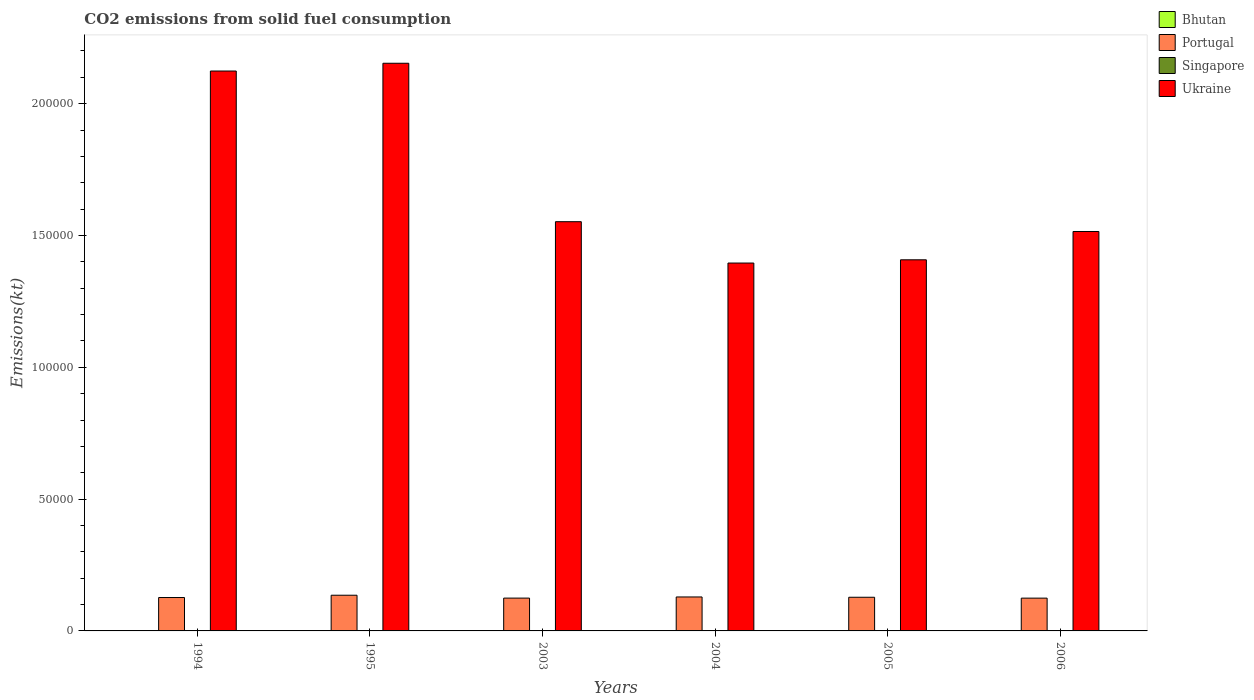Are the number of bars per tick equal to the number of legend labels?
Offer a very short reply. Yes. How many bars are there on the 6th tick from the left?
Your answer should be compact. 4. How many bars are there on the 6th tick from the right?
Keep it short and to the point. 4. What is the label of the 3rd group of bars from the left?
Provide a short and direct response. 2003. What is the amount of CO2 emitted in Ukraine in 2005?
Make the answer very short. 1.41e+05. Across all years, what is the maximum amount of CO2 emitted in Bhutan?
Offer a very short reply. 110.01. Across all years, what is the minimum amount of CO2 emitted in Portugal?
Offer a terse response. 1.24e+04. In which year was the amount of CO2 emitted in Ukraine maximum?
Ensure brevity in your answer.  1995. In which year was the amount of CO2 emitted in Bhutan minimum?
Offer a terse response. 2004. What is the total amount of CO2 emitted in Portugal in the graph?
Your response must be concise. 7.68e+04. What is the difference between the amount of CO2 emitted in Portugal in 2005 and that in 2006?
Offer a terse response. 333.7. What is the difference between the amount of CO2 emitted in Bhutan in 2003 and the amount of CO2 emitted in Ukraine in 2004?
Give a very brief answer. -1.39e+05. What is the average amount of CO2 emitted in Portugal per year?
Your answer should be compact. 1.28e+04. In the year 2005, what is the difference between the amount of CO2 emitted in Portugal and amount of CO2 emitted in Singapore?
Make the answer very short. 1.28e+04. In how many years, is the amount of CO2 emitted in Ukraine greater than 130000 kt?
Make the answer very short. 6. What is the ratio of the amount of CO2 emitted in Ukraine in 2004 to that in 2005?
Offer a very short reply. 0.99. Is the difference between the amount of CO2 emitted in Portugal in 1995 and 2005 greater than the difference between the amount of CO2 emitted in Singapore in 1995 and 2005?
Your answer should be compact. Yes. What is the difference between the highest and the second highest amount of CO2 emitted in Bhutan?
Your answer should be very brief. 11. What is the difference between the highest and the lowest amount of CO2 emitted in Bhutan?
Ensure brevity in your answer.  84.34. In how many years, is the amount of CO2 emitted in Portugal greater than the average amount of CO2 emitted in Portugal taken over all years?
Give a very brief answer. 2. Is it the case that in every year, the sum of the amount of CO2 emitted in Ukraine and amount of CO2 emitted in Singapore is greater than the sum of amount of CO2 emitted in Portugal and amount of CO2 emitted in Bhutan?
Make the answer very short. Yes. What does the 2nd bar from the left in 1995 represents?
Keep it short and to the point. Portugal. What does the 4th bar from the right in 1995 represents?
Give a very brief answer. Bhutan. Is it the case that in every year, the sum of the amount of CO2 emitted in Bhutan and amount of CO2 emitted in Ukraine is greater than the amount of CO2 emitted in Singapore?
Keep it short and to the point. Yes. Are all the bars in the graph horizontal?
Offer a terse response. No. Are the values on the major ticks of Y-axis written in scientific E-notation?
Your answer should be compact. No. Where does the legend appear in the graph?
Your answer should be compact. Top right. How many legend labels are there?
Offer a very short reply. 4. What is the title of the graph?
Ensure brevity in your answer.  CO2 emissions from solid fuel consumption. Does "Brazil" appear as one of the legend labels in the graph?
Offer a terse response. No. What is the label or title of the X-axis?
Give a very brief answer. Years. What is the label or title of the Y-axis?
Your response must be concise. Emissions(kt). What is the Emissions(kt) in Bhutan in 1994?
Provide a succinct answer. 62.34. What is the Emissions(kt) of Portugal in 1994?
Give a very brief answer. 1.27e+04. What is the Emissions(kt) of Singapore in 1994?
Your response must be concise. 88.01. What is the Emissions(kt) in Ukraine in 1994?
Your response must be concise. 2.12e+05. What is the Emissions(kt) of Bhutan in 1995?
Make the answer very short. 77.01. What is the Emissions(kt) in Portugal in 1995?
Your answer should be very brief. 1.35e+04. What is the Emissions(kt) in Singapore in 1995?
Offer a very short reply. 40.34. What is the Emissions(kt) in Ukraine in 1995?
Your answer should be very brief. 2.15e+05. What is the Emissions(kt) of Bhutan in 2003?
Provide a succinct answer. 110.01. What is the Emissions(kt) of Portugal in 2003?
Offer a very short reply. 1.24e+04. What is the Emissions(kt) of Singapore in 2003?
Provide a short and direct response. 33. What is the Emissions(kt) of Ukraine in 2003?
Provide a succinct answer. 1.55e+05. What is the Emissions(kt) in Bhutan in 2004?
Give a very brief answer. 25.67. What is the Emissions(kt) of Portugal in 2004?
Provide a short and direct response. 1.29e+04. What is the Emissions(kt) of Singapore in 2004?
Make the answer very short. 40.34. What is the Emissions(kt) in Ukraine in 2004?
Provide a short and direct response. 1.40e+05. What is the Emissions(kt) in Bhutan in 2005?
Offer a very short reply. 99.01. What is the Emissions(kt) in Portugal in 2005?
Offer a very short reply. 1.28e+04. What is the Emissions(kt) of Singapore in 2005?
Give a very brief answer. 11. What is the Emissions(kt) in Ukraine in 2005?
Your answer should be very brief. 1.41e+05. What is the Emissions(kt) of Bhutan in 2006?
Make the answer very short. 84.34. What is the Emissions(kt) of Portugal in 2006?
Provide a succinct answer. 1.24e+04. What is the Emissions(kt) of Singapore in 2006?
Your response must be concise. 14.67. What is the Emissions(kt) in Ukraine in 2006?
Make the answer very short. 1.52e+05. Across all years, what is the maximum Emissions(kt) in Bhutan?
Your response must be concise. 110.01. Across all years, what is the maximum Emissions(kt) of Portugal?
Your answer should be compact. 1.35e+04. Across all years, what is the maximum Emissions(kt) of Singapore?
Provide a short and direct response. 88.01. Across all years, what is the maximum Emissions(kt) in Ukraine?
Provide a short and direct response. 2.15e+05. Across all years, what is the minimum Emissions(kt) of Bhutan?
Offer a very short reply. 25.67. Across all years, what is the minimum Emissions(kt) in Portugal?
Make the answer very short. 1.24e+04. Across all years, what is the minimum Emissions(kt) in Singapore?
Keep it short and to the point. 11. Across all years, what is the minimum Emissions(kt) in Ukraine?
Provide a succinct answer. 1.40e+05. What is the total Emissions(kt) of Bhutan in the graph?
Offer a very short reply. 458.38. What is the total Emissions(kt) in Portugal in the graph?
Make the answer very short. 7.68e+04. What is the total Emissions(kt) of Singapore in the graph?
Your answer should be compact. 227.35. What is the total Emissions(kt) in Ukraine in the graph?
Your answer should be compact. 1.01e+06. What is the difference between the Emissions(kt) of Bhutan in 1994 and that in 1995?
Offer a very short reply. -14.67. What is the difference between the Emissions(kt) in Portugal in 1994 and that in 1995?
Give a very brief answer. -869.08. What is the difference between the Emissions(kt) in Singapore in 1994 and that in 1995?
Your answer should be compact. 47.67. What is the difference between the Emissions(kt) of Ukraine in 1994 and that in 1995?
Provide a short and direct response. -2948.27. What is the difference between the Emissions(kt) in Bhutan in 1994 and that in 2003?
Your answer should be very brief. -47.67. What is the difference between the Emissions(kt) in Portugal in 1994 and that in 2003?
Your answer should be compact. 220.02. What is the difference between the Emissions(kt) of Singapore in 1994 and that in 2003?
Provide a short and direct response. 55.01. What is the difference between the Emissions(kt) of Ukraine in 1994 and that in 2003?
Provide a succinct answer. 5.72e+04. What is the difference between the Emissions(kt) in Bhutan in 1994 and that in 2004?
Provide a short and direct response. 36.67. What is the difference between the Emissions(kt) of Portugal in 1994 and that in 2004?
Keep it short and to the point. -216.35. What is the difference between the Emissions(kt) in Singapore in 1994 and that in 2004?
Offer a very short reply. 47.67. What is the difference between the Emissions(kt) of Ukraine in 1994 and that in 2004?
Your response must be concise. 7.28e+04. What is the difference between the Emissions(kt) in Bhutan in 1994 and that in 2005?
Make the answer very short. -36.67. What is the difference between the Emissions(kt) of Portugal in 1994 and that in 2005?
Give a very brief answer. -102.68. What is the difference between the Emissions(kt) of Singapore in 1994 and that in 2005?
Offer a very short reply. 77.01. What is the difference between the Emissions(kt) of Ukraine in 1994 and that in 2005?
Give a very brief answer. 7.16e+04. What is the difference between the Emissions(kt) of Bhutan in 1994 and that in 2006?
Your response must be concise. -22. What is the difference between the Emissions(kt) in Portugal in 1994 and that in 2006?
Your response must be concise. 231.02. What is the difference between the Emissions(kt) of Singapore in 1994 and that in 2006?
Your answer should be compact. 73.34. What is the difference between the Emissions(kt) of Ukraine in 1994 and that in 2006?
Your answer should be very brief. 6.09e+04. What is the difference between the Emissions(kt) of Bhutan in 1995 and that in 2003?
Offer a very short reply. -33. What is the difference between the Emissions(kt) in Portugal in 1995 and that in 2003?
Your answer should be compact. 1089.1. What is the difference between the Emissions(kt) in Singapore in 1995 and that in 2003?
Give a very brief answer. 7.33. What is the difference between the Emissions(kt) in Ukraine in 1995 and that in 2003?
Provide a short and direct response. 6.01e+04. What is the difference between the Emissions(kt) of Bhutan in 1995 and that in 2004?
Provide a short and direct response. 51.34. What is the difference between the Emissions(kt) in Portugal in 1995 and that in 2004?
Offer a very short reply. 652.73. What is the difference between the Emissions(kt) in Singapore in 1995 and that in 2004?
Give a very brief answer. 0. What is the difference between the Emissions(kt) of Ukraine in 1995 and that in 2004?
Your response must be concise. 7.58e+04. What is the difference between the Emissions(kt) in Bhutan in 1995 and that in 2005?
Your response must be concise. -22. What is the difference between the Emissions(kt) of Portugal in 1995 and that in 2005?
Offer a very short reply. 766.4. What is the difference between the Emissions(kt) of Singapore in 1995 and that in 2005?
Your response must be concise. 29.34. What is the difference between the Emissions(kt) of Ukraine in 1995 and that in 2005?
Provide a short and direct response. 7.46e+04. What is the difference between the Emissions(kt) of Bhutan in 1995 and that in 2006?
Your answer should be compact. -7.33. What is the difference between the Emissions(kt) of Portugal in 1995 and that in 2006?
Provide a short and direct response. 1100.1. What is the difference between the Emissions(kt) in Singapore in 1995 and that in 2006?
Offer a terse response. 25.67. What is the difference between the Emissions(kt) in Ukraine in 1995 and that in 2006?
Offer a terse response. 6.38e+04. What is the difference between the Emissions(kt) in Bhutan in 2003 and that in 2004?
Offer a very short reply. 84.34. What is the difference between the Emissions(kt) in Portugal in 2003 and that in 2004?
Your answer should be compact. -436.37. What is the difference between the Emissions(kt) of Singapore in 2003 and that in 2004?
Provide a short and direct response. -7.33. What is the difference between the Emissions(kt) in Ukraine in 2003 and that in 2004?
Keep it short and to the point. 1.57e+04. What is the difference between the Emissions(kt) in Bhutan in 2003 and that in 2005?
Ensure brevity in your answer.  11. What is the difference between the Emissions(kt) in Portugal in 2003 and that in 2005?
Provide a short and direct response. -322.7. What is the difference between the Emissions(kt) in Singapore in 2003 and that in 2005?
Make the answer very short. 22. What is the difference between the Emissions(kt) of Ukraine in 2003 and that in 2005?
Ensure brevity in your answer.  1.45e+04. What is the difference between the Emissions(kt) in Bhutan in 2003 and that in 2006?
Offer a very short reply. 25.67. What is the difference between the Emissions(kt) of Portugal in 2003 and that in 2006?
Provide a short and direct response. 11. What is the difference between the Emissions(kt) of Singapore in 2003 and that in 2006?
Ensure brevity in your answer.  18.34. What is the difference between the Emissions(kt) in Ukraine in 2003 and that in 2006?
Offer a very short reply. 3714.67. What is the difference between the Emissions(kt) in Bhutan in 2004 and that in 2005?
Provide a short and direct response. -73.34. What is the difference between the Emissions(kt) of Portugal in 2004 and that in 2005?
Your answer should be very brief. 113.68. What is the difference between the Emissions(kt) in Singapore in 2004 and that in 2005?
Offer a terse response. 29.34. What is the difference between the Emissions(kt) of Ukraine in 2004 and that in 2005?
Offer a very short reply. -1224.78. What is the difference between the Emissions(kt) in Bhutan in 2004 and that in 2006?
Your response must be concise. -58.67. What is the difference between the Emissions(kt) in Portugal in 2004 and that in 2006?
Make the answer very short. 447.37. What is the difference between the Emissions(kt) of Singapore in 2004 and that in 2006?
Your response must be concise. 25.67. What is the difference between the Emissions(kt) in Ukraine in 2004 and that in 2006?
Your answer should be compact. -1.20e+04. What is the difference between the Emissions(kt) in Bhutan in 2005 and that in 2006?
Provide a succinct answer. 14.67. What is the difference between the Emissions(kt) in Portugal in 2005 and that in 2006?
Your response must be concise. 333.7. What is the difference between the Emissions(kt) of Singapore in 2005 and that in 2006?
Give a very brief answer. -3.67. What is the difference between the Emissions(kt) of Ukraine in 2005 and that in 2006?
Provide a succinct answer. -1.07e+04. What is the difference between the Emissions(kt) of Bhutan in 1994 and the Emissions(kt) of Portugal in 1995?
Make the answer very short. -1.35e+04. What is the difference between the Emissions(kt) of Bhutan in 1994 and the Emissions(kt) of Singapore in 1995?
Give a very brief answer. 22. What is the difference between the Emissions(kt) of Bhutan in 1994 and the Emissions(kt) of Ukraine in 1995?
Provide a succinct answer. -2.15e+05. What is the difference between the Emissions(kt) of Portugal in 1994 and the Emissions(kt) of Singapore in 1995?
Provide a short and direct response. 1.26e+04. What is the difference between the Emissions(kt) in Portugal in 1994 and the Emissions(kt) in Ukraine in 1995?
Give a very brief answer. -2.03e+05. What is the difference between the Emissions(kt) in Singapore in 1994 and the Emissions(kt) in Ukraine in 1995?
Your answer should be very brief. -2.15e+05. What is the difference between the Emissions(kt) of Bhutan in 1994 and the Emissions(kt) of Portugal in 2003?
Give a very brief answer. -1.24e+04. What is the difference between the Emissions(kt) in Bhutan in 1994 and the Emissions(kt) in Singapore in 2003?
Ensure brevity in your answer.  29.34. What is the difference between the Emissions(kt) of Bhutan in 1994 and the Emissions(kt) of Ukraine in 2003?
Provide a succinct answer. -1.55e+05. What is the difference between the Emissions(kt) of Portugal in 1994 and the Emissions(kt) of Singapore in 2003?
Ensure brevity in your answer.  1.26e+04. What is the difference between the Emissions(kt) of Portugal in 1994 and the Emissions(kt) of Ukraine in 2003?
Offer a terse response. -1.43e+05. What is the difference between the Emissions(kt) of Singapore in 1994 and the Emissions(kt) of Ukraine in 2003?
Provide a succinct answer. -1.55e+05. What is the difference between the Emissions(kt) of Bhutan in 1994 and the Emissions(kt) of Portugal in 2004?
Keep it short and to the point. -1.28e+04. What is the difference between the Emissions(kt) in Bhutan in 1994 and the Emissions(kt) in Singapore in 2004?
Ensure brevity in your answer.  22. What is the difference between the Emissions(kt) in Bhutan in 1994 and the Emissions(kt) in Ukraine in 2004?
Offer a very short reply. -1.40e+05. What is the difference between the Emissions(kt) of Portugal in 1994 and the Emissions(kt) of Singapore in 2004?
Your answer should be compact. 1.26e+04. What is the difference between the Emissions(kt) in Portugal in 1994 and the Emissions(kt) in Ukraine in 2004?
Make the answer very short. -1.27e+05. What is the difference between the Emissions(kt) in Singapore in 1994 and the Emissions(kt) in Ukraine in 2004?
Provide a succinct answer. -1.39e+05. What is the difference between the Emissions(kt) in Bhutan in 1994 and the Emissions(kt) in Portugal in 2005?
Ensure brevity in your answer.  -1.27e+04. What is the difference between the Emissions(kt) in Bhutan in 1994 and the Emissions(kt) in Singapore in 2005?
Your answer should be compact. 51.34. What is the difference between the Emissions(kt) in Bhutan in 1994 and the Emissions(kt) in Ukraine in 2005?
Make the answer very short. -1.41e+05. What is the difference between the Emissions(kt) in Portugal in 1994 and the Emissions(kt) in Singapore in 2005?
Your answer should be compact. 1.27e+04. What is the difference between the Emissions(kt) in Portugal in 1994 and the Emissions(kt) in Ukraine in 2005?
Offer a terse response. -1.28e+05. What is the difference between the Emissions(kt) in Singapore in 1994 and the Emissions(kt) in Ukraine in 2005?
Make the answer very short. -1.41e+05. What is the difference between the Emissions(kt) of Bhutan in 1994 and the Emissions(kt) of Portugal in 2006?
Make the answer very short. -1.24e+04. What is the difference between the Emissions(kt) of Bhutan in 1994 and the Emissions(kt) of Singapore in 2006?
Provide a succinct answer. 47.67. What is the difference between the Emissions(kt) in Bhutan in 1994 and the Emissions(kt) in Ukraine in 2006?
Your response must be concise. -1.51e+05. What is the difference between the Emissions(kt) in Portugal in 1994 and the Emissions(kt) in Singapore in 2006?
Offer a very short reply. 1.27e+04. What is the difference between the Emissions(kt) of Portugal in 1994 and the Emissions(kt) of Ukraine in 2006?
Your answer should be very brief. -1.39e+05. What is the difference between the Emissions(kt) in Singapore in 1994 and the Emissions(kt) in Ukraine in 2006?
Provide a short and direct response. -1.51e+05. What is the difference between the Emissions(kt) of Bhutan in 1995 and the Emissions(kt) of Portugal in 2003?
Offer a very short reply. -1.24e+04. What is the difference between the Emissions(kt) of Bhutan in 1995 and the Emissions(kt) of Singapore in 2003?
Your answer should be compact. 44. What is the difference between the Emissions(kt) of Bhutan in 1995 and the Emissions(kt) of Ukraine in 2003?
Offer a terse response. -1.55e+05. What is the difference between the Emissions(kt) of Portugal in 1995 and the Emissions(kt) of Singapore in 2003?
Provide a succinct answer. 1.35e+04. What is the difference between the Emissions(kt) of Portugal in 1995 and the Emissions(kt) of Ukraine in 2003?
Keep it short and to the point. -1.42e+05. What is the difference between the Emissions(kt) of Singapore in 1995 and the Emissions(kt) of Ukraine in 2003?
Your response must be concise. -1.55e+05. What is the difference between the Emissions(kt) of Bhutan in 1995 and the Emissions(kt) of Portugal in 2004?
Keep it short and to the point. -1.28e+04. What is the difference between the Emissions(kt) of Bhutan in 1995 and the Emissions(kt) of Singapore in 2004?
Offer a very short reply. 36.67. What is the difference between the Emissions(kt) in Bhutan in 1995 and the Emissions(kt) in Ukraine in 2004?
Offer a very short reply. -1.39e+05. What is the difference between the Emissions(kt) in Portugal in 1995 and the Emissions(kt) in Singapore in 2004?
Offer a very short reply. 1.35e+04. What is the difference between the Emissions(kt) of Portugal in 1995 and the Emissions(kt) of Ukraine in 2004?
Make the answer very short. -1.26e+05. What is the difference between the Emissions(kt) of Singapore in 1995 and the Emissions(kt) of Ukraine in 2004?
Keep it short and to the point. -1.40e+05. What is the difference between the Emissions(kt) of Bhutan in 1995 and the Emissions(kt) of Portugal in 2005?
Give a very brief answer. -1.27e+04. What is the difference between the Emissions(kt) of Bhutan in 1995 and the Emissions(kt) of Singapore in 2005?
Provide a short and direct response. 66.01. What is the difference between the Emissions(kt) of Bhutan in 1995 and the Emissions(kt) of Ukraine in 2005?
Make the answer very short. -1.41e+05. What is the difference between the Emissions(kt) in Portugal in 1995 and the Emissions(kt) in Singapore in 2005?
Provide a short and direct response. 1.35e+04. What is the difference between the Emissions(kt) of Portugal in 1995 and the Emissions(kt) of Ukraine in 2005?
Provide a succinct answer. -1.27e+05. What is the difference between the Emissions(kt) in Singapore in 1995 and the Emissions(kt) in Ukraine in 2005?
Your response must be concise. -1.41e+05. What is the difference between the Emissions(kt) of Bhutan in 1995 and the Emissions(kt) of Portugal in 2006?
Make the answer very short. -1.24e+04. What is the difference between the Emissions(kt) in Bhutan in 1995 and the Emissions(kt) in Singapore in 2006?
Keep it short and to the point. 62.34. What is the difference between the Emissions(kt) of Bhutan in 1995 and the Emissions(kt) of Ukraine in 2006?
Make the answer very short. -1.51e+05. What is the difference between the Emissions(kt) of Portugal in 1995 and the Emissions(kt) of Singapore in 2006?
Your answer should be compact. 1.35e+04. What is the difference between the Emissions(kt) in Portugal in 1995 and the Emissions(kt) in Ukraine in 2006?
Make the answer very short. -1.38e+05. What is the difference between the Emissions(kt) of Singapore in 1995 and the Emissions(kt) of Ukraine in 2006?
Offer a terse response. -1.51e+05. What is the difference between the Emissions(kt) in Bhutan in 2003 and the Emissions(kt) in Portugal in 2004?
Your answer should be compact. -1.28e+04. What is the difference between the Emissions(kt) in Bhutan in 2003 and the Emissions(kt) in Singapore in 2004?
Your answer should be very brief. 69.67. What is the difference between the Emissions(kt) of Bhutan in 2003 and the Emissions(kt) of Ukraine in 2004?
Your response must be concise. -1.39e+05. What is the difference between the Emissions(kt) of Portugal in 2003 and the Emissions(kt) of Singapore in 2004?
Offer a terse response. 1.24e+04. What is the difference between the Emissions(kt) in Portugal in 2003 and the Emissions(kt) in Ukraine in 2004?
Keep it short and to the point. -1.27e+05. What is the difference between the Emissions(kt) of Singapore in 2003 and the Emissions(kt) of Ukraine in 2004?
Make the answer very short. -1.40e+05. What is the difference between the Emissions(kt) in Bhutan in 2003 and the Emissions(kt) in Portugal in 2005?
Make the answer very short. -1.27e+04. What is the difference between the Emissions(kt) of Bhutan in 2003 and the Emissions(kt) of Singapore in 2005?
Provide a short and direct response. 99.01. What is the difference between the Emissions(kt) in Bhutan in 2003 and the Emissions(kt) in Ukraine in 2005?
Provide a succinct answer. -1.41e+05. What is the difference between the Emissions(kt) in Portugal in 2003 and the Emissions(kt) in Singapore in 2005?
Keep it short and to the point. 1.24e+04. What is the difference between the Emissions(kt) in Portugal in 2003 and the Emissions(kt) in Ukraine in 2005?
Make the answer very short. -1.28e+05. What is the difference between the Emissions(kt) of Singapore in 2003 and the Emissions(kt) of Ukraine in 2005?
Provide a succinct answer. -1.41e+05. What is the difference between the Emissions(kt) in Bhutan in 2003 and the Emissions(kt) in Portugal in 2006?
Provide a short and direct response. -1.23e+04. What is the difference between the Emissions(kt) in Bhutan in 2003 and the Emissions(kt) in Singapore in 2006?
Provide a succinct answer. 95.34. What is the difference between the Emissions(kt) of Bhutan in 2003 and the Emissions(kt) of Ukraine in 2006?
Provide a succinct answer. -1.51e+05. What is the difference between the Emissions(kt) in Portugal in 2003 and the Emissions(kt) in Singapore in 2006?
Provide a succinct answer. 1.24e+04. What is the difference between the Emissions(kt) in Portugal in 2003 and the Emissions(kt) in Ukraine in 2006?
Offer a terse response. -1.39e+05. What is the difference between the Emissions(kt) of Singapore in 2003 and the Emissions(kt) of Ukraine in 2006?
Keep it short and to the point. -1.51e+05. What is the difference between the Emissions(kt) of Bhutan in 2004 and the Emissions(kt) of Portugal in 2005?
Your response must be concise. -1.27e+04. What is the difference between the Emissions(kt) in Bhutan in 2004 and the Emissions(kt) in Singapore in 2005?
Provide a succinct answer. 14.67. What is the difference between the Emissions(kt) in Bhutan in 2004 and the Emissions(kt) in Ukraine in 2005?
Your response must be concise. -1.41e+05. What is the difference between the Emissions(kt) of Portugal in 2004 and the Emissions(kt) of Singapore in 2005?
Ensure brevity in your answer.  1.29e+04. What is the difference between the Emissions(kt) in Portugal in 2004 and the Emissions(kt) in Ukraine in 2005?
Your answer should be compact. -1.28e+05. What is the difference between the Emissions(kt) in Singapore in 2004 and the Emissions(kt) in Ukraine in 2005?
Ensure brevity in your answer.  -1.41e+05. What is the difference between the Emissions(kt) in Bhutan in 2004 and the Emissions(kt) in Portugal in 2006?
Offer a terse response. -1.24e+04. What is the difference between the Emissions(kt) in Bhutan in 2004 and the Emissions(kt) in Singapore in 2006?
Keep it short and to the point. 11. What is the difference between the Emissions(kt) in Bhutan in 2004 and the Emissions(kt) in Ukraine in 2006?
Offer a very short reply. -1.52e+05. What is the difference between the Emissions(kt) in Portugal in 2004 and the Emissions(kt) in Singapore in 2006?
Your response must be concise. 1.29e+04. What is the difference between the Emissions(kt) of Portugal in 2004 and the Emissions(kt) of Ukraine in 2006?
Make the answer very short. -1.39e+05. What is the difference between the Emissions(kt) in Singapore in 2004 and the Emissions(kt) in Ukraine in 2006?
Offer a terse response. -1.51e+05. What is the difference between the Emissions(kt) of Bhutan in 2005 and the Emissions(kt) of Portugal in 2006?
Give a very brief answer. -1.23e+04. What is the difference between the Emissions(kt) in Bhutan in 2005 and the Emissions(kt) in Singapore in 2006?
Offer a very short reply. 84.34. What is the difference between the Emissions(kt) of Bhutan in 2005 and the Emissions(kt) of Ukraine in 2006?
Offer a terse response. -1.51e+05. What is the difference between the Emissions(kt) in Portugal in 2005 and the Emissions(kt) in Singapore in 2006?
Keep it short and to the point. 1.28e+04. What is the difference between the Emissions(kt) of Portugal in 2005 and the Emissions(kt) of Ukraine in 2006?
Provide a succinct answer. -1.39e+05. What is the difference between the Emissions(kt) of Singapore in 2005 and the Emissions(kt) of Ukraine in 2006?
Your response must be concise. -1.52e+05. What is the average Emissions(kt) of Bhutan per year?
Your answer should be compact. 76.4. What is the average Emissions(kt) of Portugal per year?
Offer a terse response. 1.28e+04. What is the average Emissions(kt) in Singapore per year?
Your response must be concise. 37.89. What is the average Emissions(kt) of Ukraine per year?
Make the answer very short. 1.69e+05. In the year 1994, what is the difference between the Emissions(kt) of Bhutan and Emissions(kt) of Portugal?
Your answer should be compact. -1.26e+04. In the year 1994, what is the difference between the Emissions(kt) of Bhutan and Emissions(kt) of Singapore?
Make the answer very short. -25.67. In the year 1994, what is the difference between the Emissions(kt) in Bhutan and Emissions(kt) in Ukraine?
Provide a short and direct response. -2.12e+05. In the year 1994, what is the difference between the Emissions(kt) in Portugal and Emissions(kt) in Singapore?
Offer a very short reply. 1.26e+04. In the year 1994, what is the difference between the Emissions(kt) of Portugal and Emissions(kt) of Ukraine?
Your response must be concise. -2.00e+05. In the year 1994, what is the difference between the Emissions(kt) of Singapore and Emissions(kt) of Ukraine?
Ensure brevity in your answer.  -2.12e+05. In the year 1995, what is the difference between the Emissions(kt) of Bhutan and Emissions(kt) of Portugal?
Provide a short and direct response. -1.35e+04. In the year 1995, what is the difference between the Emissions(kt) of Bhutan and Emissions(kt) of Singapore?
Your answer should be compact. 36.67. In the year 1995, what is the difference between the Emissions(kt) in Bhutan and Emissions(kt) in Ukraine?
Make the answer very short. -2.15e+05. In the year 1995, what is the difference between the Emissions(kt) in Portugal and Emissions(kt) in Singapore?
Offer a terse response. 1.35e+04. In the year 1995, what is the difference between the Emissions(kt) of Portugal and Emissions(kt) of Ukraine?
Provide a short and direct response. -2.02e+05. In the year 1995, what is the difference between the Emissions(kt) of Singapore and Emissions(kt) of Ukraine?
Provide a succinct answer. -2.15e+05. In the year 2003, what is the difference between the Emissions(kt) in Bhutan and Emissions(kt) in Portugal?
Provide a succinct answer. -1.23e+04. In the year 2003, what is the difference between the Emissions(kt) in Bhutan and Emissions(kt) in Singapore?
Make the answer very short. 77.01. In the year 2003, what is the difference between the Emissions(kt) of Bhutan and Emissions(kt) of Ukraine?
Offer a very short reply. -1.55e+05. In the year 2003, what is the difference between the Emissions(kt) of Portugal and Emissions(kt) of Singapore?
Make the answer very short. 1.24e+04. In the year 2003, what is the difference between the Emissions(kt) of Portugal and Emissions(kt) of Ukraine?
Provide a succinct answer. -1.43e+05. In the year 2003, what is the difference between the Emissions(kt) in Singapore and Emissions(kt) in Ukraine?
Ensure brevity in your answer.  -1.55e+05. In the year 2004, what is the difference between the Emissions(kt) of Bhutan and Emissions(kt) of Portugal?
Provide a succinct answer. -1.29e+04. In the year 2004, what is the difference between the Emissions(kt) in Bhutan and Emissions(kt) in Singapore?
Give a very brief answer. -14.67. In the year 2004, what is the difference between the Emissions(kt) of Bhutan and Emissions(kt) of Ukraine?
Ensure brevity in your answer.  -1.40e+05. In the year 2004, what is the difference between the Emissions(kt) in Portugal and Emissions(kt) in Singapore?
Make the answer very short. 1.28e+04. In the year 2004, what is the difference between the Emissions(kt) of Portugal and Emissions(kt) of Ukraine?
Make the answer very short. -1.27e+05. In the year 2004, what is the difference between the Emissions(kt) in Singapore and Emissions(kt) in Ukraine?
Your answer should be very brief. -1.40e+05. In the year 2005, what is the difference between the Emissions(kt) of Bhutan and Emissions(kt) of Portugal?
Ensure brevity in your answer.  -1.27e+04. In the year 2005, what is the difference between the Emissions(kt) in Bhutan and Emissions(kt) in Singapore?
Provide a succinct answer. 88.01. In the year 2005, what is the difference between the Emissions(kt) in Bhutan and Emissions(kt) in Ukraine?
Keep it short and to the point. -1.41e+05. In the year 2005, what is the difference between the Emissions(kt) of Portugal and Emissions(kt) of Singapore?
Offer a terse response. 1.28e+04. In the year 2005, what is the difference between the Emissions(kt) of Portugal and Emissions(kt) of Ukraine?
Your answer should be very brief. -1.28e+05. In the year 2005, what is the difference between the Emissions(kt) of Singapore and Emissions(kt) of Ukraine?
Offer a terse response. -1.41e+05. In the year 2006, what is the difference between the Emissions(kt) of Bhutan and Emissions(kt) of Portugal?
Ensure brevity in your answer.  -1.24e+04. In the year 2006, what is the difference between the Emissions(kt) in Bhutan and Emissions(kt) in Singapore?
Give a very brief answer. 69.67. In the year 2006, what is the difference between the Emissions(kt) of Bhutan and Emissions(kt) of Ukraine?
Make the answer very short. -1.51e+05. In the year 2006, what is the difference between the Emissions(kt) of Portugal and Emissions(kt) of Singapore?
Give a very brief answer. 1.24e+04. In the year 2006, what is the difference between the Emissions(kt) of Portugal and Emissions(kt) of Ukraine?
Provide a short and direct response. -1.39e+05. In the year 2006, what is the difference between the Emissions(kt) of Singapore and Emissions(kt) of Ukraine?
Make the answer very short. -1.52e+05. What is the ratio of the Emissions(kt) in Bhutan in 1994 to that in 1995?
Make the answer very short. 0.81. What is the ratio of the Emissions(kt) of Portugal in 1994 to that in 1995?
Provide a short and direct response. 0.94. What is the ratio of the Emissions(kt) of Singapore in 1994 to that in 1995?
Offer a terse response. 2.18. What is the ratio of the Emissions(kt) of Ukraine in 1994 to that in 1995?
Keep it short and to the point. 0.99. What is the ratio of the Emissions(kt) in Bhutan in 1994 to that in 2003?
Your response must be concise. 0.57. What is the ratio of the Emissions(kt) in Portugal in 1994 to that in 2003?
Give a very brief answer. 1.02. What is the ratio of the Emissions(kt) of Singapore in 1994 to that in 2003?
Provide a succinct answer. 2.67. What is the ratio of the Emissions(kt) of Ukraine in 1994 to that in 2003?
Ensure brevity in your answer.  1.37. What is the ratio of the Emissions(kt) of Bhutan in 1994 to that in 2004?
Provide a succinct answer. 2.43. What is the ratio of the Emissions(kt) in Portugal in 1994 to that in 2004?
Ensure brevity in your answer.  0.98. What is the ratio of the Emissions(kt) in Singapore in 1994 to that in 2004?
Provide a short and direct response. 2.18. What is the ratio of the Emissions(kt) of Ukraine in 1994 to that in 2004?
Provide a short and direct response. 1.52. What is the ratio of the Emissions(kt) of Bhutan in 1994 to that in 2005?
Make the answer very short. 0.63. What is the ratio of the Emissions(kt) in Ukraine in 1994 to that in 2005?
Your response must be concise. 1.51. What is the ratio of the Emissions(kt) in Bhutan in 1994 to that in 2006?
Your answer should be very brief. 0.74. What is the ratio of the Emissions(kt) of Portugal in 1994 to that in 2006?
Offer a terse response. 1.02. What is the ratio of the Emissions(kt) in Ukraine in 1994 to that in 2006?
Give a very brief answer. 1.4. What is the ratio of the Emissions(kt) in Portugal in 1995 to that in 2003?
Ensure brevity in your answer.  1.09. What is the ratio of the Emissions(kt) of Singapore in 1995 to that in 2003?
Your response must be concise. 1.22. What is the ratio of the Emissions(kt) of Ukraine in 1995 to that in 2003?
Make the answer very short. 1.39. What is the ratio of the Emissions(kt) of Bhutan in 1995 to that in 2004?
Keep it short and to the point. 3. What is the ratio of the Emissions(kt) in Portugal in 1995 to that in 2004?
Make the answer very short. 1.05. What is the ratio of the Emissions(kt) in Ukraine in 1995 to that in 2004?
Your answer should be very brief. 1.54. What is the ratio of the Emissions(kt) of Bhutan in 1995 to that in 2005?
Ensure brevity in your answer.  0.78. What is the ratio of the Emissions(kt) of Portugal in 1995 to that in 2005?
Your answer should be compact. 1.06. What is the ratio of the Emissions(kt) in Singapore in 1995 to that in 2005?
Keep it short and to the point. 3.67. What is the ratio of the Emissions(kt) in Ukraine in 1995 to that in 2005?
Make the answer very short. 1.53. What is the ratio of the Emissions(kt) in Bhutan in 1995 to that in 2006?
Provide a short and direct response. 0.91. What is the ratio of the Emissions(kt) of Portugal in 1995 to that in 2006?
Offer a very short reply. 1.09. What is the ratio of the Emissions(kt) of Singapore in 1995 to that in 2006?
Offer a very short reply. 2.75. What is the ratio of the Emissions(kt) in Ukraine in 1995 to that in 2006?
Make the answer very short. 1.42. What is the ratio of the Emissions(kt) of Bhutan in 2003 to that in 2004?
Offer a very short reply. 4.29. What is the ratio of the Emissions(kt) in Portugal in 2003 to that in 2004?
Your answer should be compact. 0.97. What is the ratio of the Emissions(kt) in Singapore in 2003 to that in 2004?
Offer a very short reply. 0.82. What is the ratio of the Emissions(kt) in Ukraine in 2003 to that in 2004?
Keep it short and to the point. 1.11. What is the ratio of the Emissions(kt) in Portugal in 2003 to that in 2005?
Offer a terse response. 0.97. What is the ratio of the Emissions(kt) in Ukraine in 2003 to that in 2005?
Offer a terse response. 1.1. What is the ratio of the Emissions(kt) in Bhutan in 2003 to that in 2006?
Provide a short and direct response. 1.3. What is the ratio of the Emissions(kt) of Portugal in 2003 to that in 2006?
Offer a terse response. 1. What is the ratio of the Emissions(kt) of Singapore in 2003 to that in 2006?
Offer a very short reply. 2.25. What is the ratio of the Emissions(kt) in Ukraine in 2003 to that in 2006?
Your answer should be compact. 1.02. What is the ratio of the Emissions(kt) in Bhutan in 2004 to that in 2005?
Your answer should be compact. 0.26. What is the ratio of the Emissions(kt) of Portugal in 2004 to that in 2005?
Ensure brevity in your answer.  1.01. What is the ratio of the Emissions(kt) in Singapore in 2004 to that in 2005?
Your answer should be very brief. 3.67. What is the ratio of the Emissions(kt) in Bhutan in 2004 to that in 2006?
Offer a terse response. 0.3. What is the ratio of the Emissions(kt) of Portugal in 2004 to that in 2006?
Make the answer very short. 1.04. What is the ratio of the Emissions(kt) of Singapore in 2004 to that in 2006?
Ensure brevity in your answer.  2.75. What is the ratio of the Emissions(kt) of Ukraine in 2004 to that in 2006?
Give a very brief answer. 0.92. What is the ratio of the Emissions(kt) in Bhutan in 2005 to that in 2006?
Offer a terse response. 1.17. What is the ratio of the Emissions(kt) in Portugal in 2005 to that in 2006?
Ensure brevity in your answer.  1.03. What is the ratio of the Emissions(kt) of Ukraine in 2005 to that in 2006?
Offer a terse response. 0.93. What is the difference between the highest and the second highest Emissions(kt) in Bhutan?
Offer a very short reply. 11. What is the difference between the highest and the second highest Emissions(kt) in Portugal?
Offer a very short reply. 652.73. What is the difference between the highest and the second highest Emissions(kt) in Singapore?
Provide a short and direct response. 47.67. What is the difference between the highest and the second highest Emissions(kt) in Ukraine?
Ensure brevity in your answer.  2948.27. What is the difference between the highest and the lowest Emissions(kt) of Bhutan?
Keep it short and to the point. 84.34. What is the difference between the highest and the lowest Emissions(kt) in Portugal?
Make the answer very short. 1100.1. What is the difference between the highest and the lowest Emissions(kt) of Singapore?
Keep it short and to the point. 77.01. What is the difference between the highest and the lowest Emissions(kt) of Ukraine?
Give a very brief answer. 7.58e+04. 